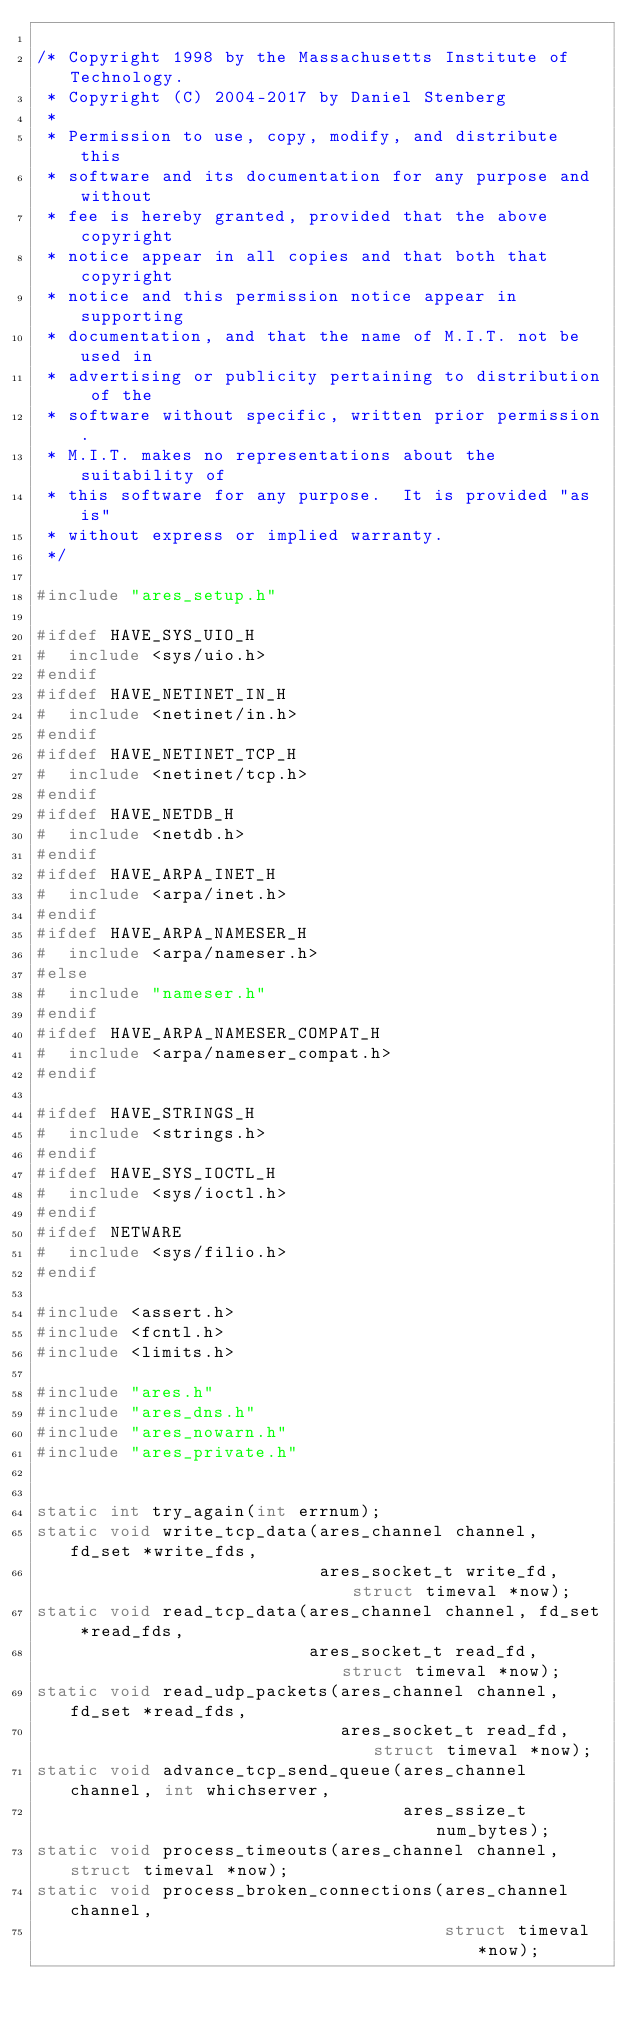<code> <loc_0><loc_0><loc_500><loc_500><_C_>
/* Copyright 1998 by the Massachusetts Institute of Technology.
 * Copyright (C) 2004-2017 by Daniel Stenberg
 *
 * Permission to use, copy, modify, and distribute this
 * software and its documentation for any purpose and without
 * fee is hereby granted, provided that the above copyright
 * notice appear in all copies and that both that copyright
 * notice and this permission notice appear in supporting
 * documentation, and that the name of M.I.T. not be used in
 * advertising or publicity pertaining to distribution of the
 * software without specific, written prior permission.
 * M.I.T. makes no representations about the suitability of
 * this software for any purpose.  It is provided "as is"
 * without express or implied warranty.
 */

#include "ares_setup.h"

#ifdef HAVE_SYS_UIO_H
#  include <sys/uio.h>
#endif
#ifdef HAVE_NETINET_IN_H
#  include <netinet/in.h>
#endif
#ifdef HAVE_NETINET_TCP_H
#  include <netinet/tcp.h>
#endif
#ifdef HAVE_NETDB_H
#  include <netdb.h>
#endif
#ifdef HAVE_ARPA_INET_H
#  include <arpa/inet.h>
#endif
#ifdef HAVE_ARPA_NAMESER_H
#  include <arpa/nameser.h>
#else
#  include "nameser.h"
#endif
#ifdef HAVE_ARPA_NAMESER_COMPAT_H
#  include <arpa/nameser_compat.h>
#endif

#ifdef HAVE_STRINGS_H
#  include <strings.h>
#endif
#ifdef HAVE_SYS_IOCTL_H
#  include <sys/ioctl.h>
#endif
#ifdef NETWARE
#  include <sys/filio.h>
#endif

#include <assert.h>
#include <fcntl.h>
#include <limits.h>

#include "ares.h"
#include "ares_dns.h"
#include "ares_nowarn.h"
#include "ares_private.h"


static int try_again(int errnum);
static void write_tcp_data(ares_channel channel, fd_set *write_fds,
                           ares_socket_t write_fd, struct timeval *now);
static void read_tcp_data(ares_channel channel, fd_set *read_fds,
                          ares_socket_t read_fd, struct timeval *now);
static void read_udp_packets(ares_channel channel, fd_set *read_fds,
                             ares_socket_t read_fd, struct timeval *now);
static void advance_tcp_send_queue(ares_channel channel, int whichserver,
                                   ares_ssize_t num_bytes);
static void process_timeouts(ares_channel channel, struct timeval *now);
static void process_broken_connections(ares_channel channel,
                                       struct timeval *now);</code> 